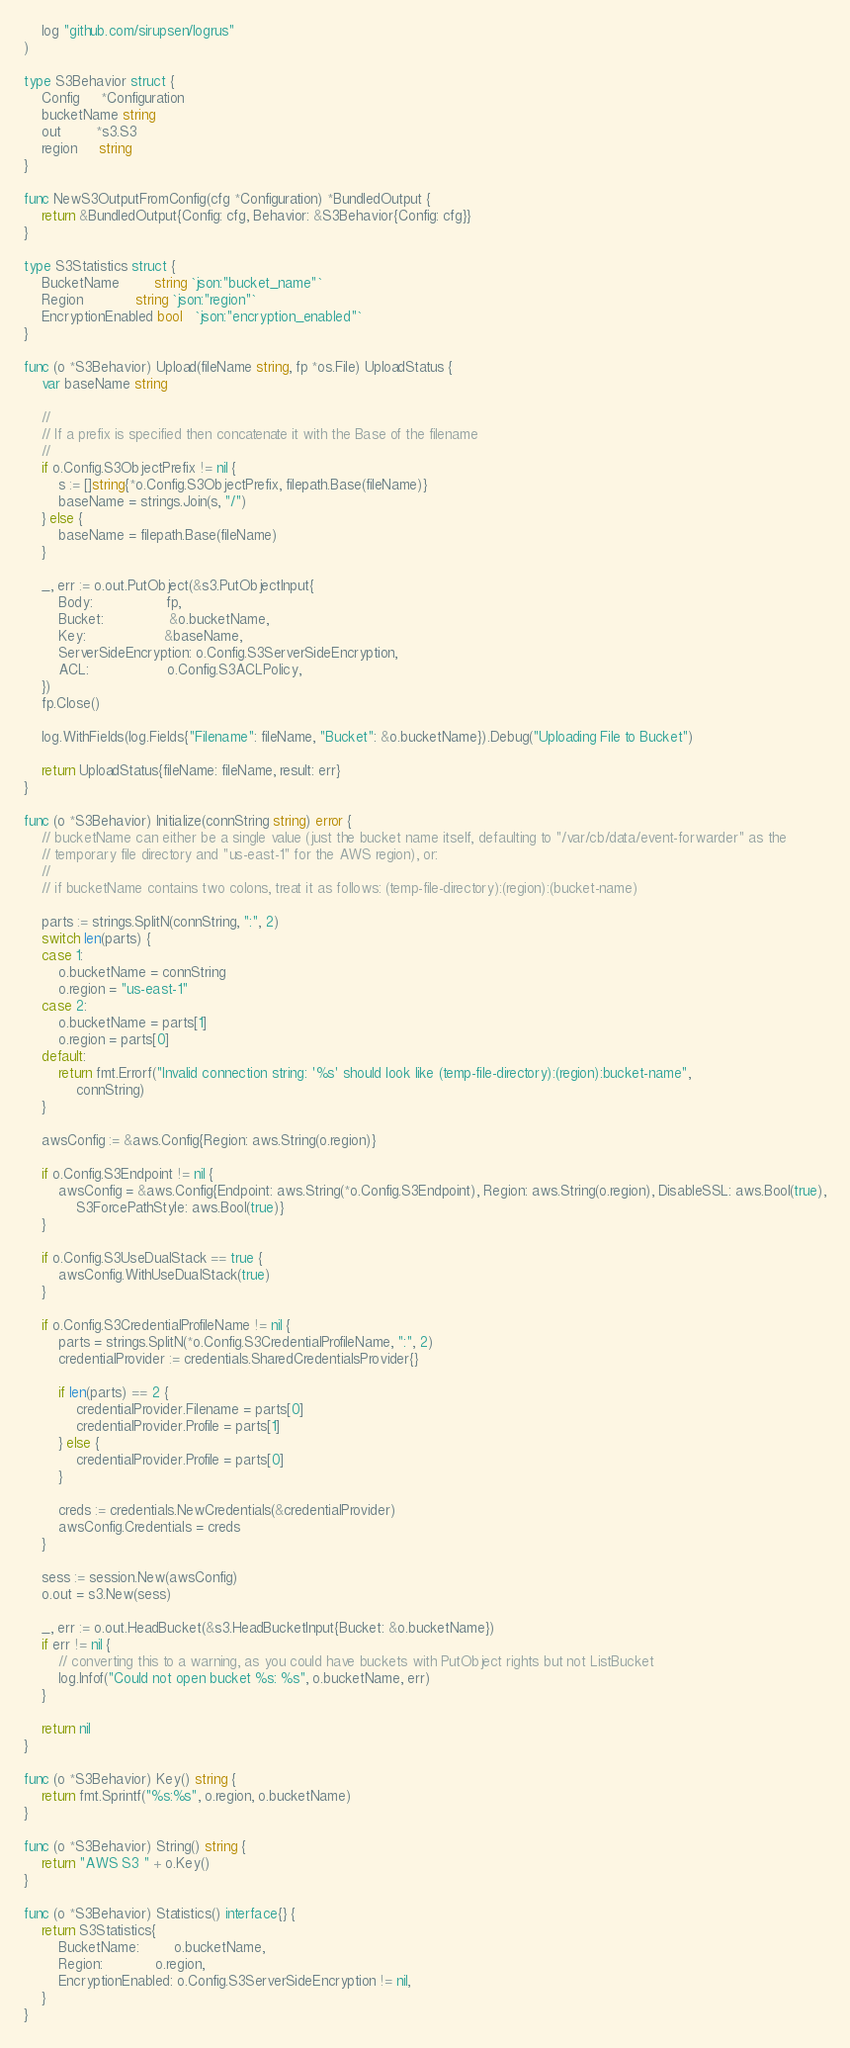Convert code to text. <code><loc_0><loc_0><loc_500><loc_500><_Go_>	log "github.com/sirupsen/logrus"
)

type S3Behavior struct {
	Config     *Configuration
	bucketName string
	out        *s3.S3
	region     string
}

func NewS3OutputFromConfig(cfg *Configuration) *BundledOutput {
	return &BundledOutput{Config: cfg, Behavior: &S3Behavior{Config: cfg}}
}

type S3Statistics struct {
	BucketName        string `json:"bucket_name"`
	Region            string `json:"region"`
	EncryptionEnabled bool   `json:"encryption_enabled"`
}

func (o *S3Behavior) Upload(fileName string, fp *os.File) UploadStatus {
	var baseName string

	//
	// If a prefix is specified then concatenate it with the Base of the filename
	//
	if o.Config.S3ObjectPrefix != nil {
		s := []string{*o.Config.S3ObjectPrefix, filepath.Base(fileName)}
		baseName = strings.Join(s, "/")
	} else {
		baseName = filepath.Base(fileName)
	}

	_, err := o.out.PutObject(&s3.PutObjectInput{
		Body:                 fp,
		Bucket:               &o.bucketName,
		Key:                  &baseName,
		ServerSideEncryption: o.Config.S3ServerSideEncryption,
		ACL:                  o.Config.S3ACLPolicy,
	})
	fp.Close()

	log.WithFields(log.Fields{"Filename": fileName, "Bucket": &o.bucketName}).Debug("Uploading File to Bucket")

	return UploadStatus{fileName: fileName, result: err}
}

func (o *S3Behavior) Initialize(connString string) error {
	// bucketName can either be a single value (just the bucket name itself, defaulting to "/var/cb/data/event-forwarder" as the
	// temporary file directory and "us-east-1" for the AWS region), or:
	//
	// if bucketName contains two colons, treat it as follows: (temp-file-directory):(region):(bucket-name)

	parts := strings.SplitN(connString, ":", 2)
	switch len(parts) {
	case 1:
		o.bucketName = connString
		o.region = "us-east-1"
	case 2:
		o.bucketName = parts[1]
		o.region = parts[0]
	default:
		return fmt.Errorf("Invalid connection string: '%s' should look like (temp-file-directory):(region):bucket-name",
			connString)
	}

	awsConfig := &aws.Config{Region: aws.String(o.region)}

	if o.Config.S3Endpoint != nil {
		awsConfig = &aws.Config{Endpoint: aws.String(*o.Config.S3Endpoint), Region: aws.String(o.region), DisableSSL: aws.Bool(true),
			S3ForcePathStyle: aws.Bool(true)}
	}

	if o.Config.S3UseDualStack == true {
		awsConfig.WithUseDualStack(true)
	}

	if o.Config.S3CredentialProfileName != nil {
		parts = strings.SplitN(*o.Config.S3CredentialProfileName, ":", 2)
		credentialProvider := credentials.SharedCredentialsProvider{}

		if len(parts) == 2 {
			credentialProvider.Filename = parts[0]
			credentialProvider.Profile = parts[1]
		} else {
			credentialProvider.Profile = parts[0]
		}

		creds := credentials.NewCredentials(&credentialProvider)
		awsConfig.Credentials = creds
	}

	sess := session.New(awsConfig)
	o.out = s3.New(sess)

	_, err := o.out.HeadBucket(&s3.HeadBucketInput{Bucket: &o.bucketName})
	if err != nil {
		// converting this to a warning, as you could have buckets with PutObject rights but not ListBucket
		log.Infof("Could not open bucket %s: %s", o.bucketName, err)
	}

	return nil
}

func (o *S3Behavior) Key() string {
	return fmt.Sprintf("%s:%s", o.region, o.bucketName)
}

func (o *S3Behavior) String() string {
	return "AWS S3 " + o.Key()
}

func (o *S3Behavior) Statistics() interface{} {
	return S3Statistics{
		BucketName:        o.bucketName,
		Region:            o.region,
		EncryptionEnabled: o.Config.S3ServerSideEncryption != nil,
	}
}
</code> 